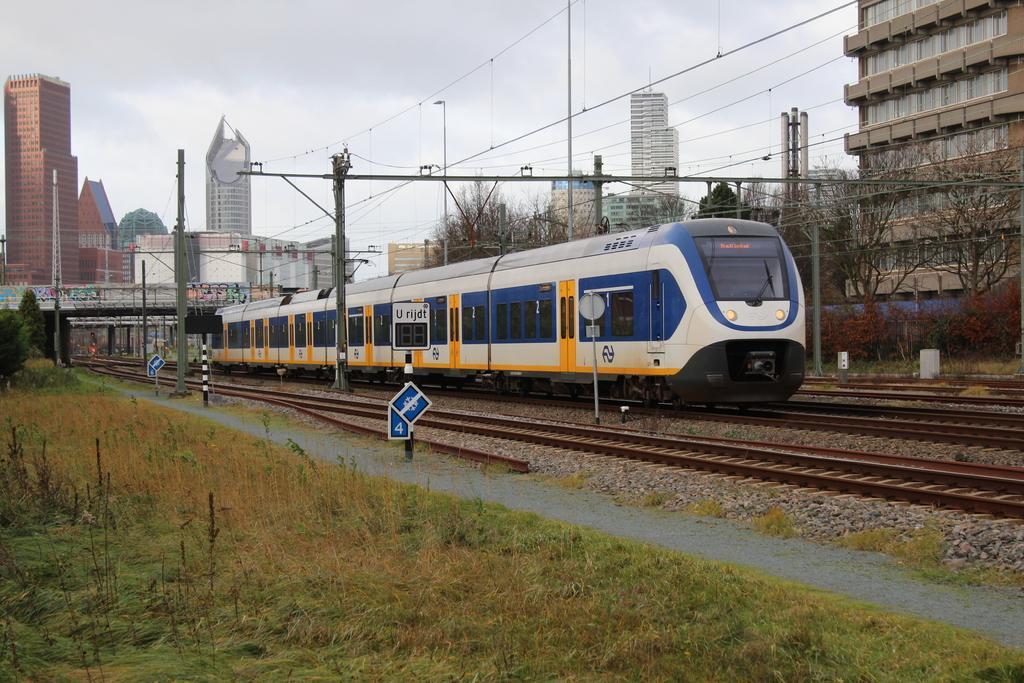In one or two sentences, can you explain what this image depicts? In the image we can see a train on the train track. Here we can see grass, path, electric pole, electric wires, buildings, trees and the cloudy sky. Here we can see the boards and plants. 